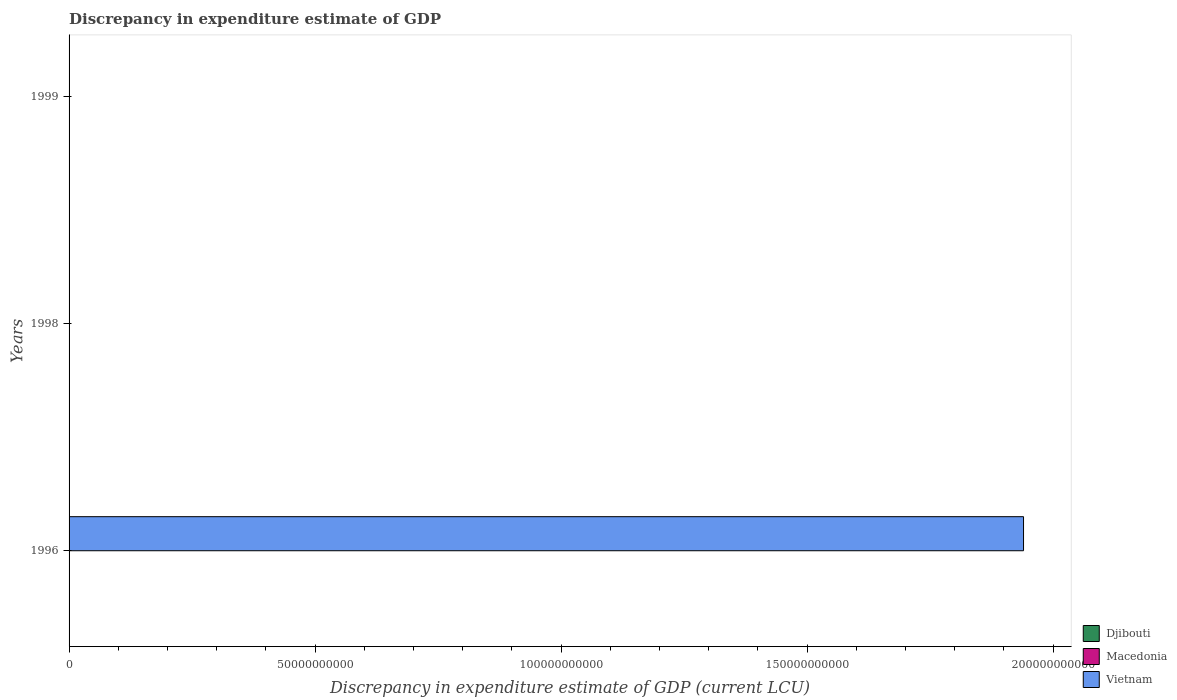Are the number of bars on each tick of the Y-axis equal?
Your response must be concise. Yes. What is the label of the 3rd group of bars from the top?
Provide a short and direct response. 1996. In how many cases, is the number of bars for a given year not equal to the number of legend labels?
Provide a short and direct response. 3. What is the discrepancy in expenditure estimate of GDP in Djibouti in 1998?
Offer a very short reply. 0. Across all years, what is the maximum discrepancy in expenditure estimate of GDP in Macedonia?
Keep it short and to the point. 1.63e+05. What is the total discrepancy in expenditure estimate of GDP in Macedonia in the graph?
Your answer should be compact. 2.48e+05. What is the difference between the discrepancy in expenditure estimate of GDP in Macedonia in 1998 and that in 1999?
Provide a short and direct response. -7.92e+04. What is the difference between the discrepancy in expenditure estimate of GDP in Vietnam in 1996 and the discrepancy in expenditure estimate of GDP in Macedonia in 1998?
Your answer should be very brief. 1.94e+11. What is the average discrepancy in expenditure estimate of GDP in Vietnam per year?
Provide a succinct answer. 6.47e+1. In how many years, is the discrepancy in expenditure estimate of GDP in Vietnam greater than 80000000000 LCU?
Give a very brief answer. 1. What is the ratio of the discrepancy in expenditure estimate of GDP in Macedonia in 1998 to that in 1999?
Offer a terse response. 0.52. What is the difference between the highest and the lowest discrepancy in expenditure estimate of GDP in Macedonia?
Ensure brevity in your answer.  1.63e+05. Is the sum of the discrepancy in expenditure estimate of GDP in Macedonia in 1998 and 1999 greater than the maximum discrepancy in expenditure estimate of GDP in Vietnam across all years?
Keep it short and to the point. No. Is it the case that in every year, the sum of the discrepancy in expenditure estimate of GDP in Djibouti and discrepancy in expenditure estimate of GDP in Vietnam is greater than the discrepancy in expenditure estimate of GDP in Macedonia?
Your answer should be compact. No. How many bars are there?
Give a very brief answer. 3. How many years are there in the graph?
Provide a succinct answer. 3. What is the difference between two consecutive major ticks on the X-axis?
Provide a succinct answer. 5.00e+1. Are the values on the major ticks of X-axis written in scientific E-notation?
Make the answer very short. No. Does the graph contain any zero values?
Give a very brief answer. Yes. Where does the legend appear in the graph?
Make the answer very short. Bottom right. How many legend labels are there?
Provide a short and direct response. 3. How are the legend labels stacked?
Offer a terse response. Vertical. What is the title of the graph?
Make the answer very short. Discrepancy in expenditure estimate of GDP. Does "Belize" appear as one of the legend labels in the graph?
Provide a short and direct response. No. What is the label or title of the X-axis?
Give a very brief answer. Discrepancy in expenditure estimate of GDP (current LCU). What is the label or title of the Y-axis?
Your answer should be very brief. Years. What is the Discrepancy in expenditure estimate of GDP (current LCU) of Djibouti in 1996?
Make the answer very short. 0. What is the Discrepancy in expenditure estimate of GDP (current LCU) in Macedonia in 1996?
Provide a succinct answer. 0. What is the Discrepancy in expenditure estimate of GDP (current LCU) in Vietnam in 1996?
Provide a succinct answer. 1.94e+11. What is the Discrepancy in expenditure estimate of GDP (current LCU) of Macedonia in 1998?
Your answer should be very brief. 8.42e+04. What is the Discrepancy in expenditure estimate of GDP (current LCU) of Macedonia in 1999?
Your answer should be very brief. 1.63e+05. Across all years, what is the maximum Discrepancy in expenditure estimate of GDP (current LCU) in Macedonia?
Give a very brief answer. 1.63e+05. Across all years, what is the maximum Discrepancy in expenditure estimate of GDP (current LCU) in Vietnam?
Ensure brevity in your answer.  1.94e+11. Across all years, what is the minimum Discrepancy in expenditure estimate of GDP (current LCU) of Macedonia?
Make the answer very short. 0. What is the total Discrepancy in expenditure estimate of GDP (current LCU) of Macedonia in the graph?
Your response must be concise. 2.48e+05. What is the total Discrepancy in expenditure estimate of GDP (current LCU) in Vietnam in the graph?
Offer a very short reply. 1.94e+11. What is the difference between the Discrepancy in expenditure estimate of GDP (current LCU) of Macedonia in 1998 and that in 1999?
Your answer should be compact. -7.92e+04. What is the average Discrepancy in expenditure estimate of GDP (current LCU) of Macedonia per year?
Your answer should be very brief. 8.25e+04. What is the average Discrepancy in expenditure estimate of GDP (current LCU) in Vietnam per year?
Provide a succinct answer. 6.47e+1. What is the ratio of the Discrepancy in expenditure estimate of GDP (current LCU) of Macedonia in 1998 to that in 1999?
Offer a terse response. 0.52. What is the difference between the highest and the lowest Discrepancy in expenditure estimate of GDP (current LCU) of Macedonia?
Offer a terse response. 1.63e+05. What is the difference between the highest and the lowest Discrepancy in expenditure estimate of GDP (current LCU) in Vietnam?
Provide a succinct answer. 1.94e+11. 